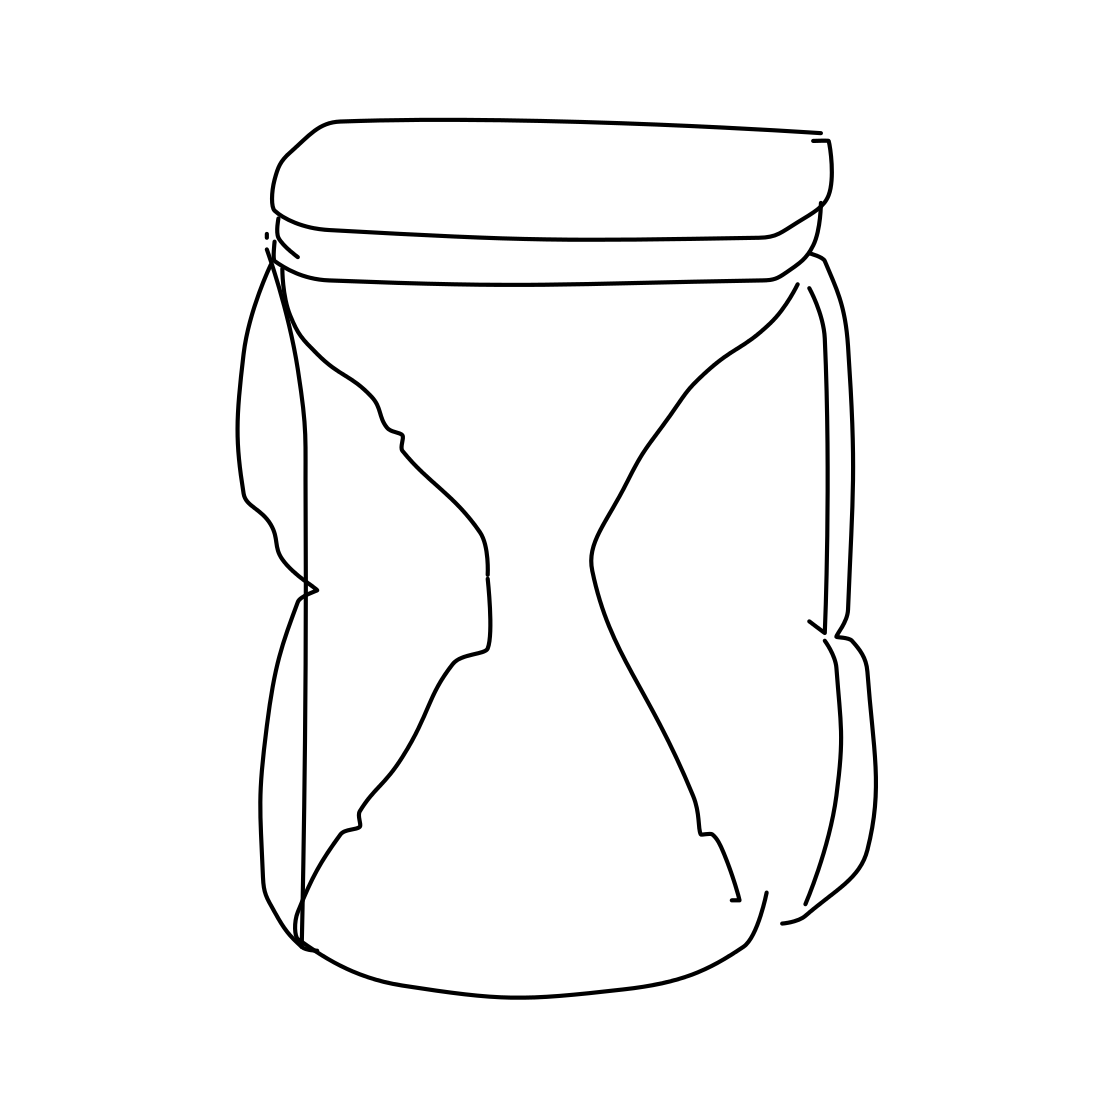Is there a sketchy telephone in the picture? No 